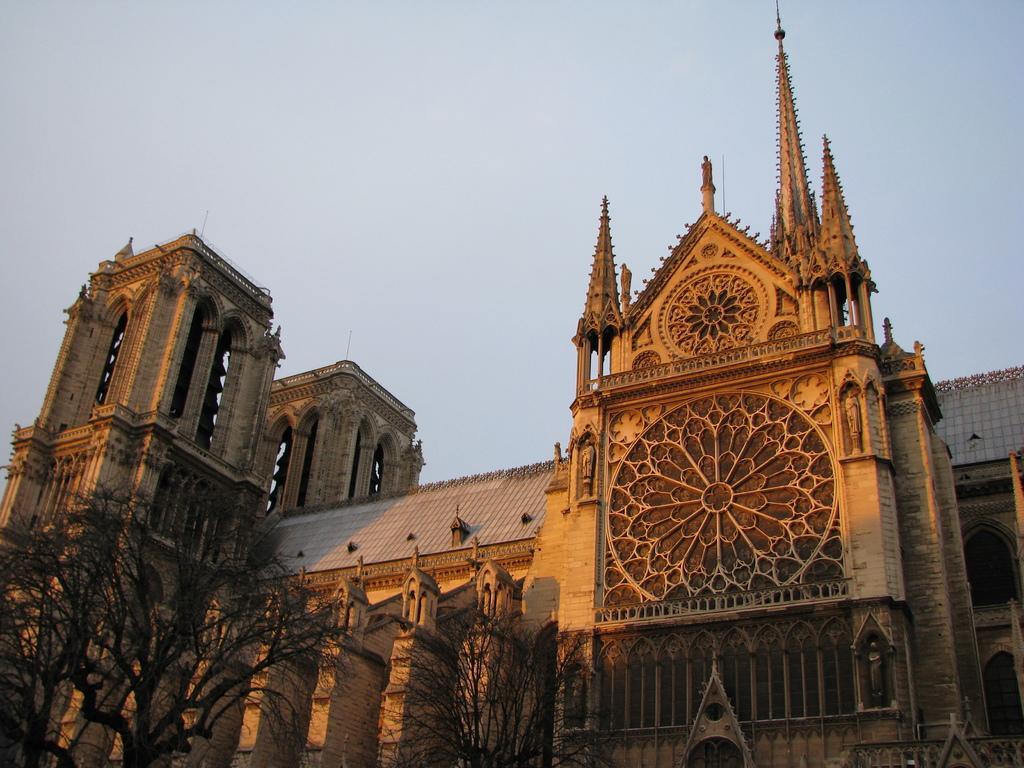How would you summarize this image in a sentence or two? In this image there are few trees at the bottom of the image. Behind there is a building. Top of the image there is sky. 